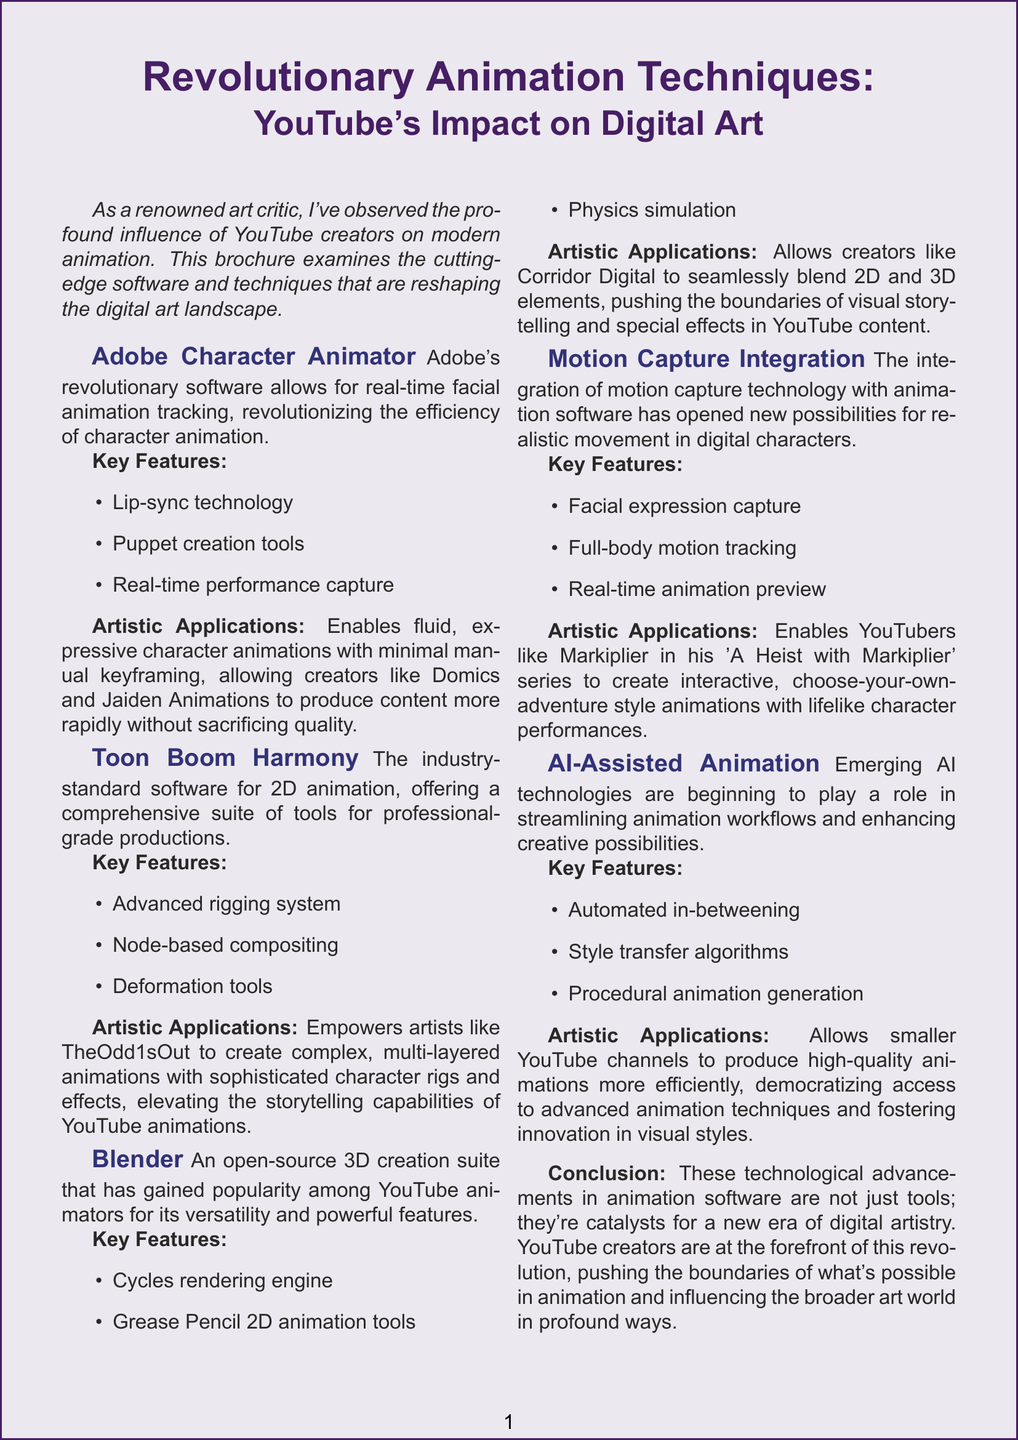What software is focused on real-time facial animation tracking? The section specifically detailing Adobe Character Animator emphasizes its capability for real-time facial animation tracking.
Answer: Adobe Character Animator Who is mentioned as a creator using Adobe Character Animator? The document cites Domics and Jaiden Animations as creators utilizing Adobe Character Animator for their content.
Answer: Domics and Jaiden Animations What is a key feature of Toon Boom Harmony? In the section about Toon Boom Harmony, advanced rigging system is listed as one of its key features.
Answer: Advanced rigging system Which software is known for its versatility and open-source nature? The document highlights Blender as the open-source 3D creation suite favored for its versatility among YouTube animators.
Answer: Blender What is the artistic application of AI-Assisted Animation? The brochure states that AI-Assisted Animation allows smaller YouTube channels to produce high-quality animations more efficiently.
Answer: High-quality animations more efficiently How does motion capture technology enhance YouTube animations? The brochure explains that motion capture technology enables realistic movement in digital characters, benefiting creators like Markiplier.
Answer: Realistic movement in digital characters What are two key features of Adobe Character Animator? The section lists lip-sync technology and real-time performance capture among its key features.
Answer: Lip-sync technology, real-time performance capture How do the software innovations mentioned impact the art world? The conclusion states these technological advancements serve as catalysts for a new era of digital artistry, influencing broader art landscapes.
Answer: Catalysts for a new era of digital artistry 